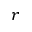<formula> <loc_0><loc_0><loc_500><loc_500>r</formula> 